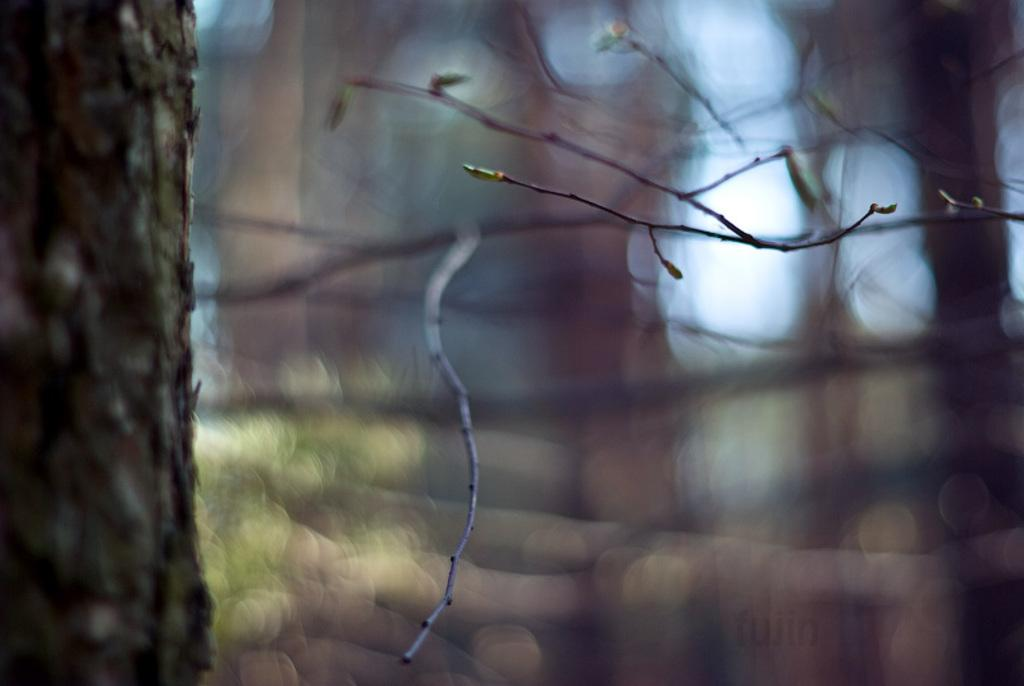What is the main object in the foreground of the image? There is a tree in front of the image. How would you describe the background of the image? The background of the image is blurred. Is there is any text present in the image? Yes, there is some text at the bottom of the image. Can you tell me how many strangers are shaking hands in the image? There are no strangers or handshakes present in the image. What is the limit of the tree's growth in the image? The image does not provide information about the tree's growth or any limits on it. 